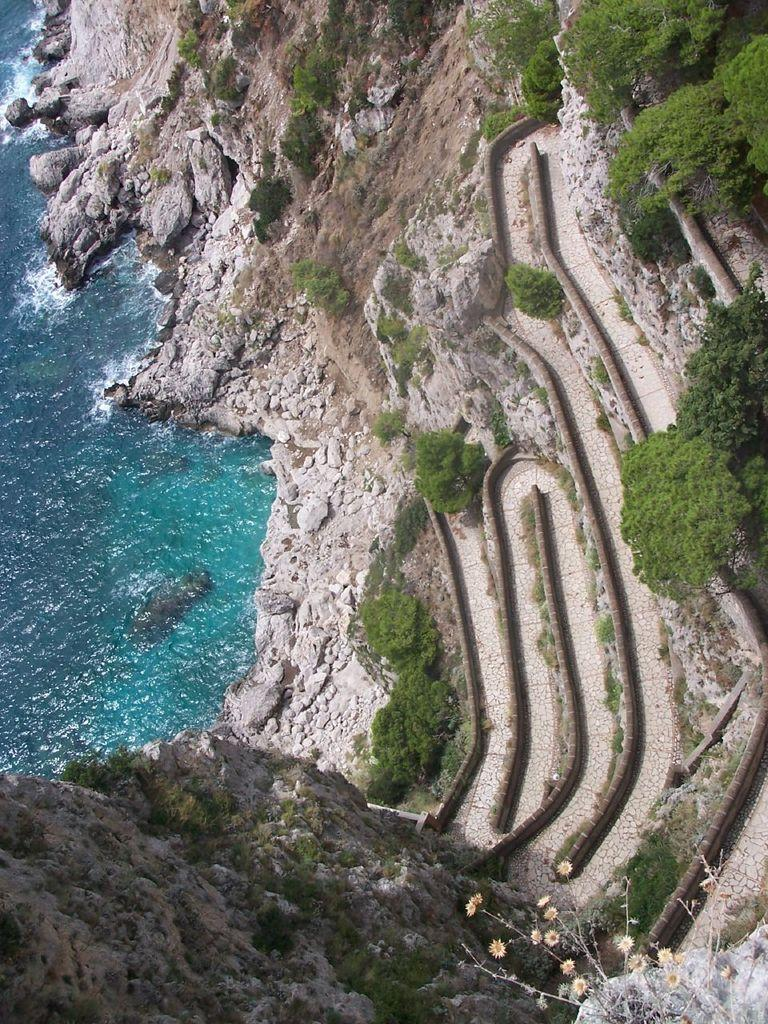What is the primary element visible in the image? There is water in the image. What type of natural features can be seen in the image? There are trees and mountains in the image. Can you describe the possible location of the image based on the visible elements? The image may have been taken near the ocean, given the presence of water. How many brothers are laughing together in the image? There are no people or brothers present in the image, so it is not possible to answer this question. 